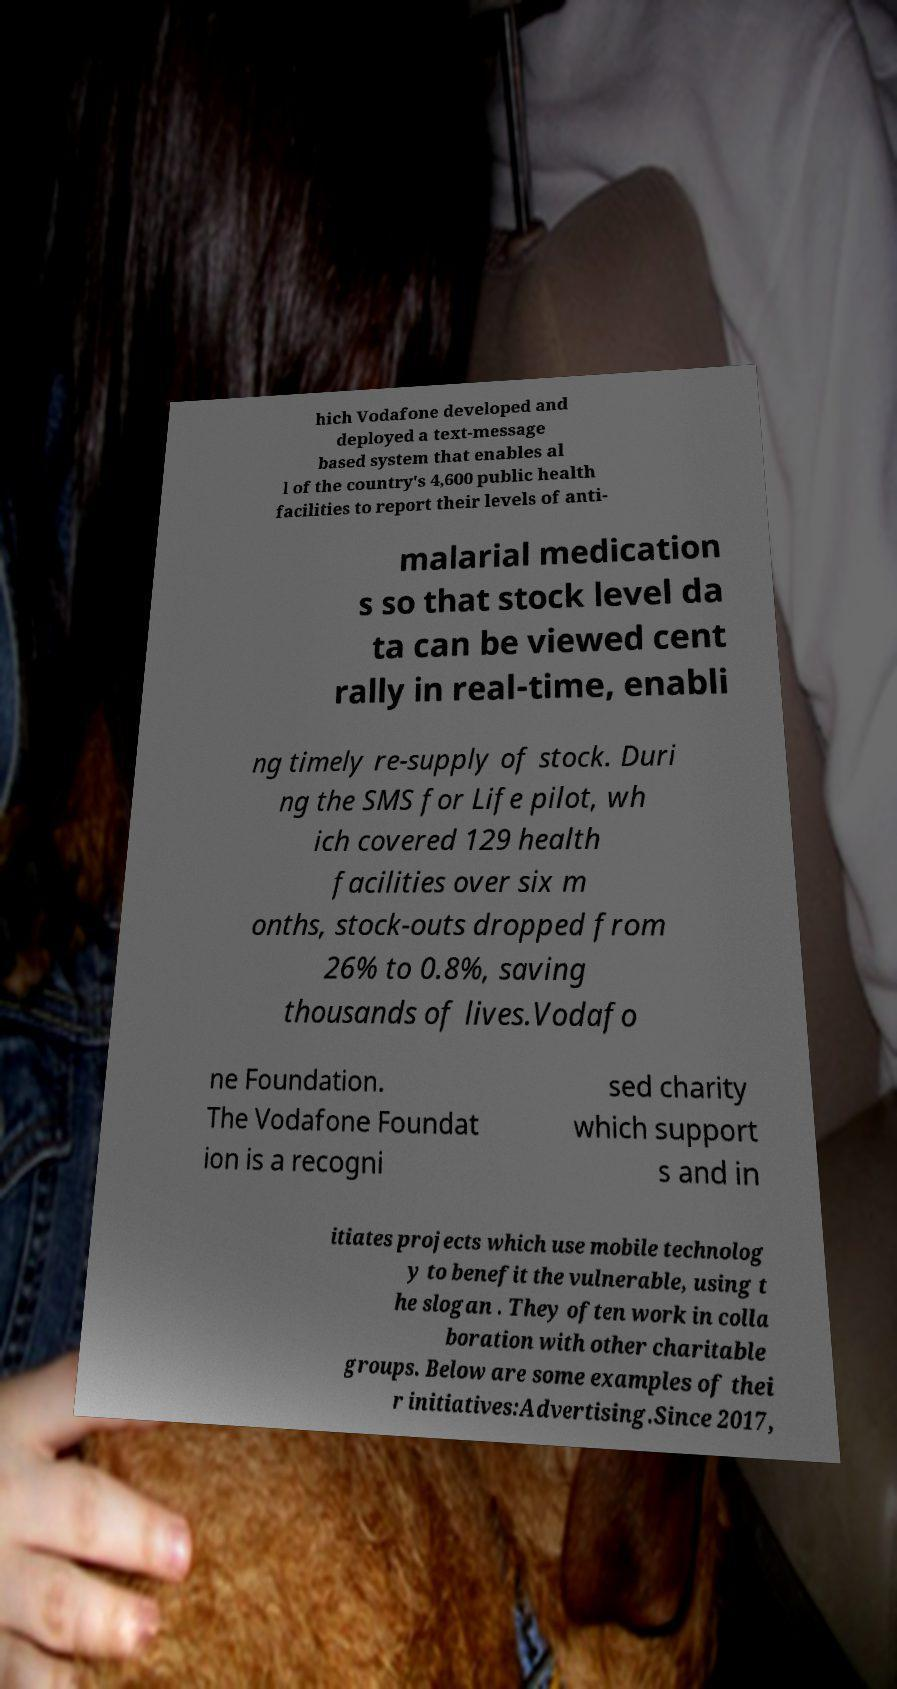Please read and relay the text visible in this image. What does it say? hich Vodafone developed and deployed a text-message based system that enables al l of the country's 4,600 public health facilities to report their levels of anti- malarial medication s so that stock level da ta can be viewed cent rally in real-time, enabli ng timely re-supply of stock. Duri ng the SMS for Life pilot, wh ich covered 129 health facilities over six m onths, stock-outs dropped from 26% to 0.8%, saving thousands of lives.Vodafo ne Foundation. The Vodafone Foundat ion is a recogni sed charity which support s and in itiates projects which use mobile technolog y to benefit the vulnerable, using t he slogan . They often work in colla boration with other charitable groups. Below are some examples of thei r initiatives:Advertising.Since 2017, 